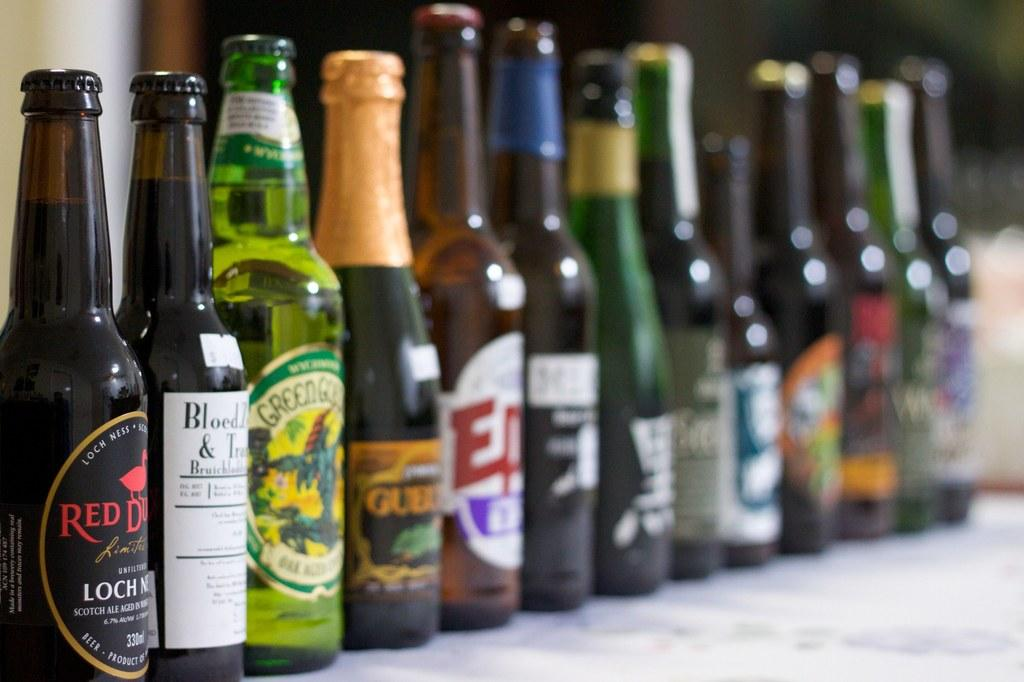<image>
Write a terse but informative summary of the picture. A bottle of scotch ale is in the left with many more bottles to the right. 